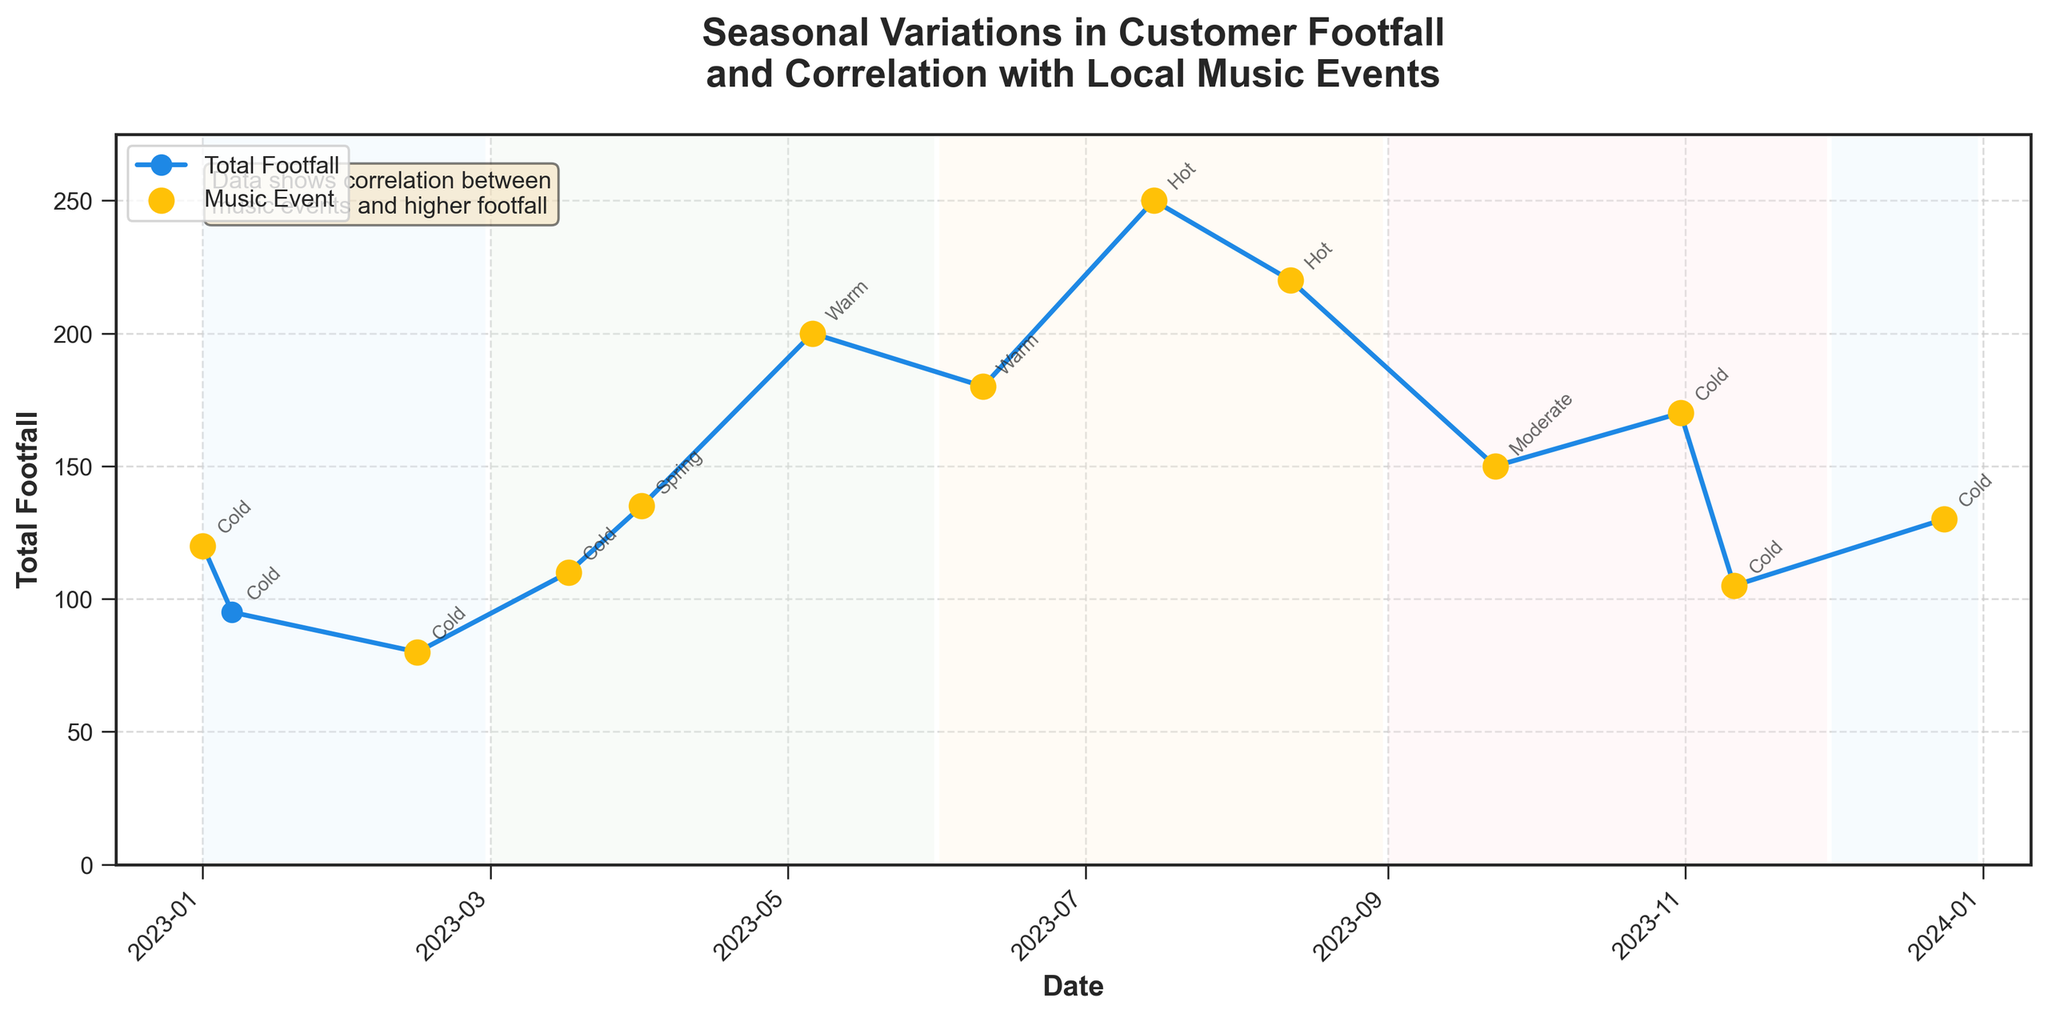What's the title of the plot? The title is clearly written at the top of the plot, and it reads, "Seasonal Variations in Customer Footfall and Correlation with Local Music Events."
Answer: Seasonal Variations in Customer Footfall and Correlation with Local Music Events What is the total footfall on Valentine's Day Special? Locate February 14 on the x-axis, which corresponds to Valentine's Day Special. The y-axis value at this point shows the total footfall.
Answer: 80 How does the footfall on Summer Festival compare to Valentine’s Day Special? Find the footfall values for both events. Summer Festival (July 15) has 250, and Valentine’s Day Special (February 14) has 80. Compare these two values.
Answer: Summer Festival has higher footfall In which season does the Early Summer Music Fest take place? Identify the date of the Early Summer Music Fest (May 6). Look at the background color for this date and match it with the legend to identify the season.
Answer: Spring What is the median footfall of all events listed? List all the footfall values and sort them: 80, 95, 105, 110, 120, 130, 135, 150, 170, 180, 200, 220, 250. The median is the middle value when the list is sorted, which is (135+150)/2.
Answer: 142.5 Which event has the highest footfall? Scan through all the plotted points and find the highest y-axis value. The corresponding event on that date is the one with the highest footfall.
Answer: Summer Festival How does cold weather impact footfall compared to hot weather? Identify the footfall values on dates with cold weather and compare the average to those on dates with hot weather. Cold: 120, 95, 80, 110, 170, 105, 130. Hot: 250, 220. Compare the averages. Cold average = (120+95+80+110+170+105+130)/7; Hot average = (250+220)/2.
Answer: Cold: 114.29, Hot: 235 What is the trend in footfall from January to July? Observe the plotted line from January to July. Note the general direction of the line - increasing or decreasing.
Answer: Increasing How many local music events are marked on the plot? Count the number of scatter points labeled with orange color, which represent local music events.
Answer: 11 